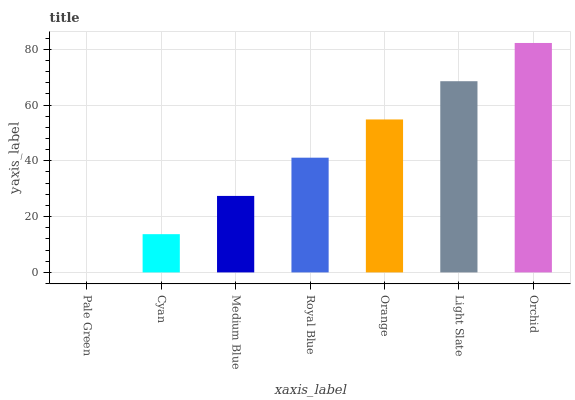Is Pale Green the minimum?
Answer yes or no. Yes. Is Orchid the maximum?
Answer yes or no. Yes. Is Cyan the minimum?
Answer yes or no. No. Is Cyan the maximum?
Answer yes or no. No. Is Cyan greater than Pale Green?
Answer yes or no. Yes. Is Pale Green less than Cyan?
Answer yes or no. Yes. Is Pale Green greater than Cyan?
Answer yes or no. No. Is Cyan less than Pale Green?
Answer yes or no. No. Is Royal Blue the high median?
Answer yes or no. Yes. Is Royal Blue the low median?
Answer yes or no. Yes. Is Pale Green the high median?
Answer yes or no. No. Is Cyan the low median?
Answer yes or no. No. 